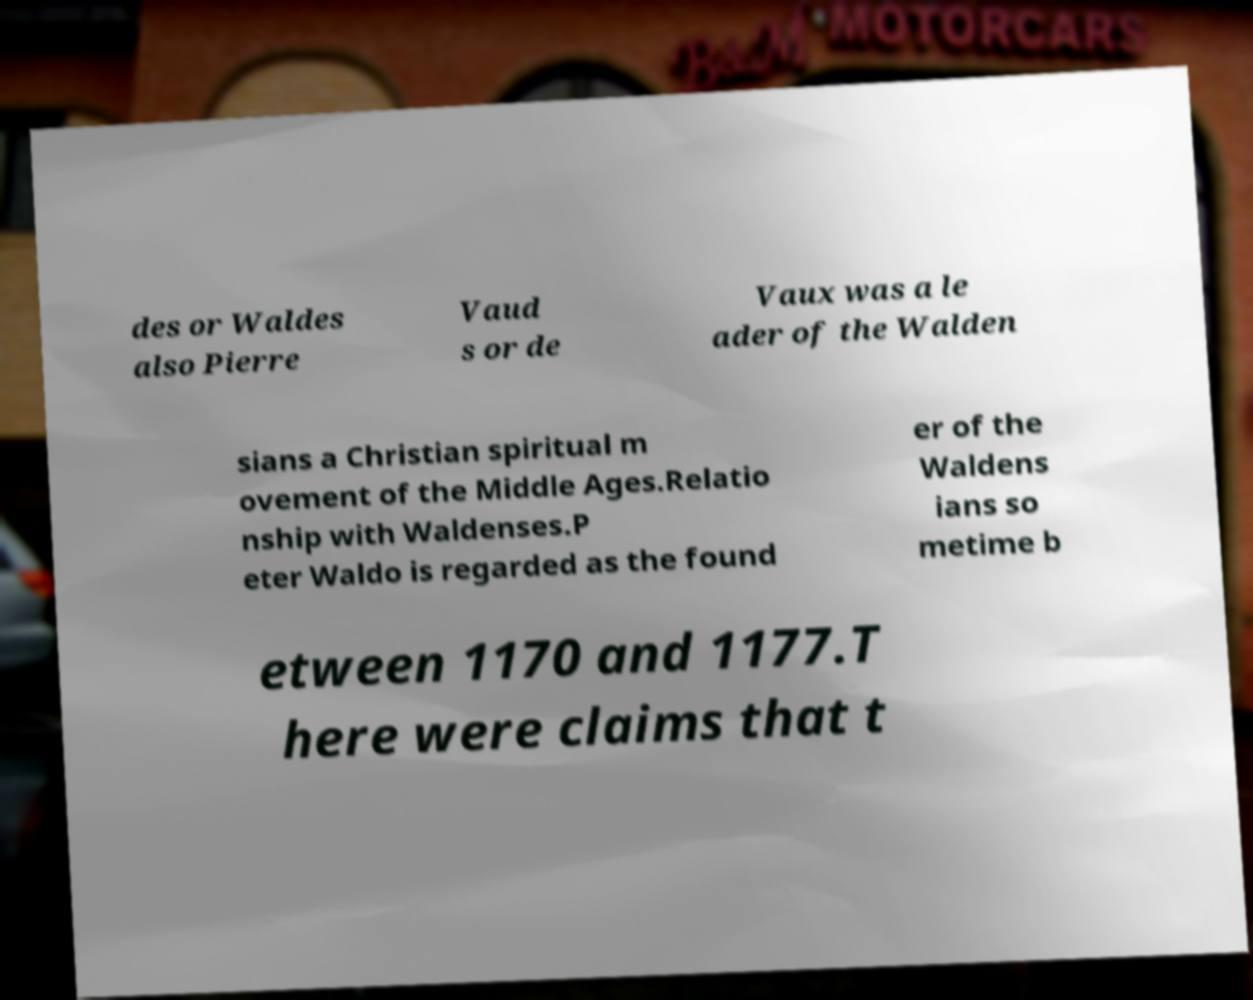I need the written content from this picture converted into text. Can you do that? des or Waldes also Pierre Vaud s or de Vaux was a le ader of the Walden sians a Christian spiritual m ovement of the Middle Ages.Relatio nship with Waldenses.P eter Waldo is regarded as the found er of the Waldens ians so metime b etween 1170 and 1177.T here were claims that t 